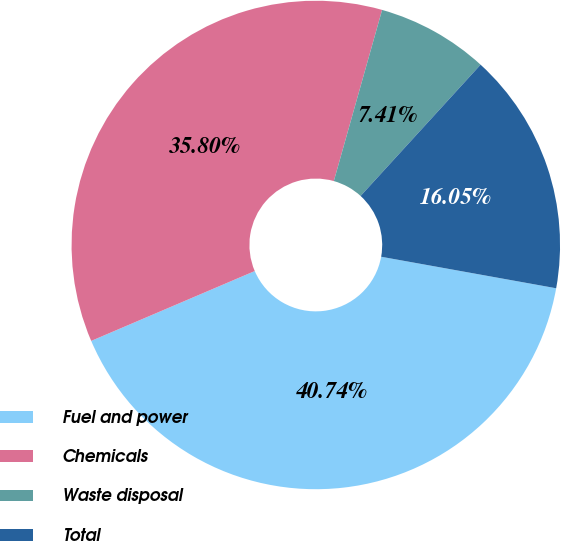Convert chart. <chart><loc_0><loc_0><loc_500><loc_500><pie_chart><fcel>Fuel and power<fcel>Chemicals<fcel>Waste disposal<fcel>Total<nl><fcel>40.74%<fcel>35.8%<fcel>7.41%<fcel>16.05%<nl></chart> 